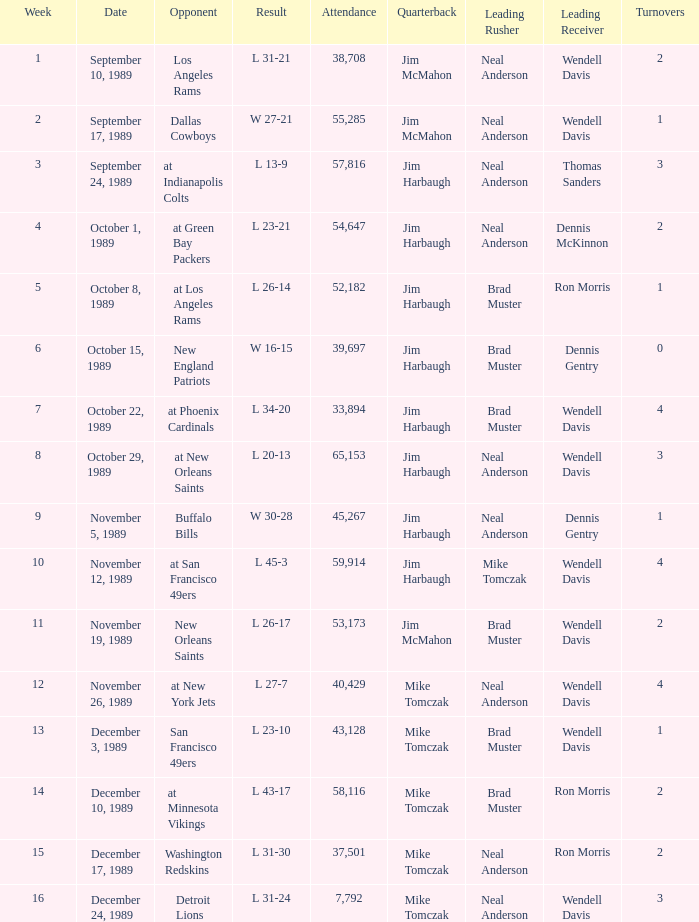The Detroit Lions were played against what week? 16.0. Parse the full table. {'header': ['Week', 'Date', 'Opponent', 'Result', 'Attendance', 'Quarterback', 'Leading Rusher', 'Leading Receiver', 'Turnovers'], 'rows': [['1', 'September 10, 1989', 'Los Angeles Rams', 'L 31-21', '38,708', 'Jim McMahon', 'Neal Anderson', 'Wendell Davis', '2'], ['2', 'September 17, 1989', 'Dallas Cowboys', 'W 27-21', '55,285', 'Jim McMahon', 'Neal Anderson', 'Wendell Davis', '1'], ['3', 'September 24, 1989', 'at Indianapolis Colts', 'L 13-9', '57,816', 'Jim Harbaugh', 'Neal Anderson', 'Thomas Sanders', '3'], ['4', 'October 1, 1989', 'at Green Bay Packers', 'L 23-21', '54,647', 'Jim Harbaugh', 'Neal Anderson', 'Dennis McKinnon', '2'], ['5', 'October 8, 1989', 'at Los Angeles Rams', 'L 26-14', '52,182', 'Jim Harbaugh', 'Brad Muster', 'Ron Morris', '1'], ['6', 'October 15, 1989', 'New England Patriots', 'W 16-15', '39,697', 'Jim Harbaugh', 'Brad Muster', 'Dennis Gentry', '0'], ['7', 'October 22, 1989', 'at Phoenix Cardinals', 'L 34-20', '33,894', 'Jim Harbaugh', 'Brad Muster', 'Wendell Davis', '4'], ['8', 'October 29, 1989', 'at New Orleans Saints', 'L 20-13', '65,153', 'Jim Harbaugh', 'Neal Anderson', 'Wendell Davis', '3'], ['9', 'November 5, 1989', 'Buffalo Bills', 'W 30-28', '45,267', 'Jim Harbaugh', 'Neal Anderson', 'Dennis Gentry', '1'], ['10', 'November 12, 1989', 'at San Francisco 49ers', 'L 45-3', '59,914', 'Jim Harbaugh', 'Mike Tomczak', 'Wendell Davis', '4'], ['11', 'November 19, 1989', 'New Orleans Saints', 'L 26-17', '53,173', 'Jim McMahon', 'Brad Muster', 'Wendell Davis', '2'], ['12', 'November 26, 1989', 'at New York Jets', 'L 27-7', '40,429', 'Mike Tomczak', 'Neal Anderson', 'Wendell Davis', '4'], ['13', 'December 3, 1989', 'San Francisco 49ers', 'L 23-10', '43,128', 'Mike Tomczak', 'Brad Muster', 'Wendell Davis', '1'], ['14', 'December 10, 1989', 'at Minnesota Vikings', 'L 43-17', '58,116', 'Mike Tomczak', 'Brad Muster', 'Ron Morris', '2'], ['15', 'December 17, 1989', 'Washington Redskins', 'L 31-30', '37,501', 'Mike Tomczak', 'Neal Anderson', 'Ron Morris', '2'], ['16', 'December 24, 1989', 'Detroit Lions', 'L 31-24', '7,792', 'Mike Tomczak', 'Neal Anderson', 'Wendell Davis', '3']]} 